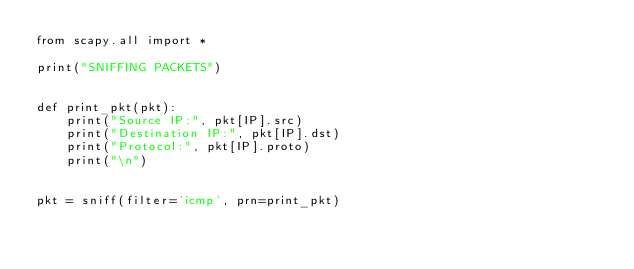<code> <loc_0><loc_0><loc_500><loc_500><_Python_>from scapy.all import *

print("SNIFFING PACKETS")


def print_pkt(pkt):
    print("Source IP:", pkt[IP].src)
    print("Destination IP:", pkt[IP].dst)
    print("Protocol:", pkt[IP].proto)
    print("\n")


pkt = sniff(filter='icmp', prn=print_pkt)
</code> 